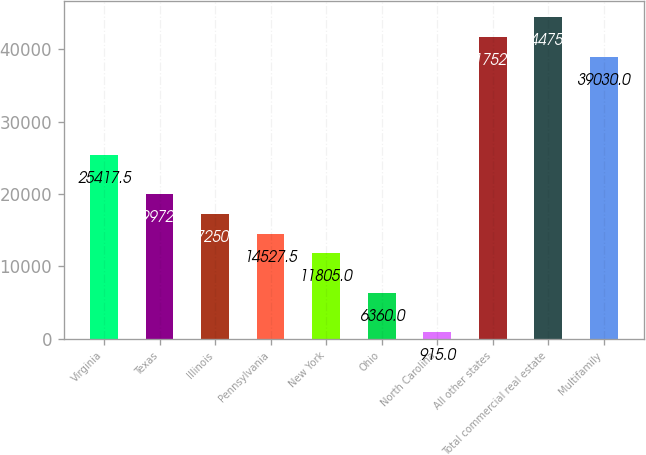<chart> <loc_0><loc_0><loc_500><loc_500><bar_chart><fcel>Virginia<fcel>Texas<fcel>Illinois<fcel>Pennsylvania<fcel>New York<fcel>Ohio<fcel>North Carolina<fcel>All other states<fcel>Total commercial real estate<fcel>Multifamily<nl><fcel>25417.5<fcel>19972.5<fcel>17250<fcel>14527.5<fcel>11805<fcel>6360<fcel>915<fcel>41752.5<fcel>44475<fcel>39030<nl></chart> 